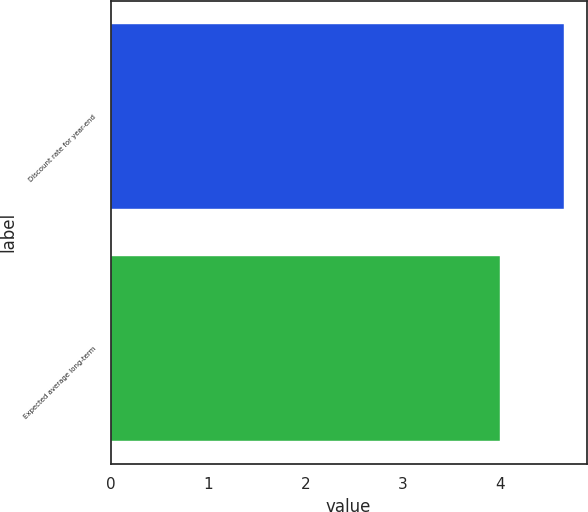<chart> <loc_0><loc_0><loc_500><loc_500><bar_chart><fcel>Discount rate for year-end<fcel>Expected average long-term<nl><fcel>4.66<fcel>4<nl></chart> 